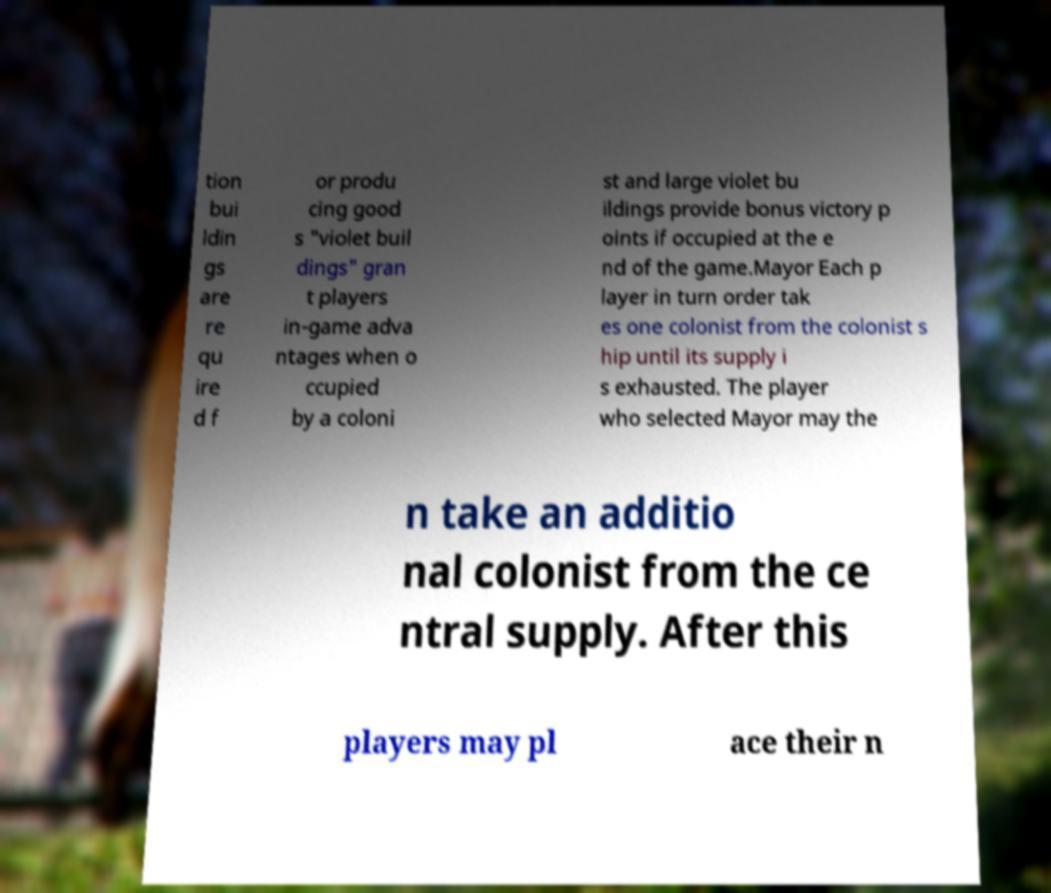What messages or text are displayed in this image? I need them in a readable, typed format. tion bui ldin gs are re qu ire d f or produ cing good s "violet buil dings" gran t players in-game adva ntages when o ccupied by a coloni st and large violet bu ildings provide bonus victory p oints if occupied at the e nd of the game.Mayor Each p layer in turn order tak es one colonist from the colonist s hip until its supply i s exhausted. The player who selected Mayor may the n take an additio nal colonist from the ce ntral supply. After this players may pl ace their n 